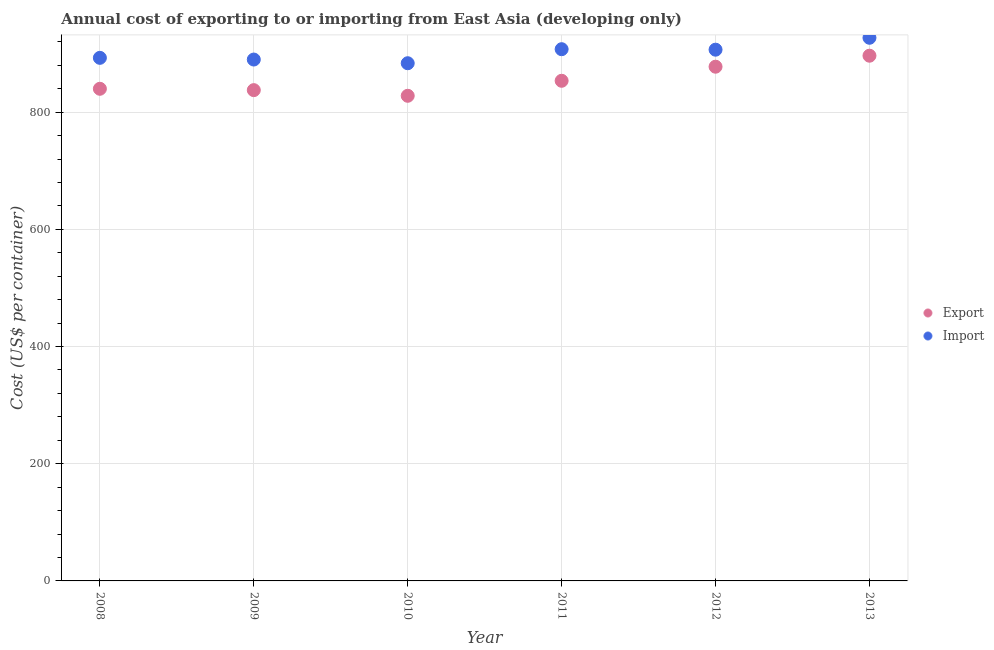Is the number of dotlines equal to the number of legend labels?
Ensure brevity in your answer.  Yes. What is the export cost in 2008?
Offer a terse response. 839.85. Across all years, what is the maximum export cost?
Provide a short and direct response. 896.3. Across all years, what is the minimum export cost?
Ensure brevity in your answer.  827.9. In which year was the export cost minimum?
Your answer should be very brief. 2010. What is the total export cost in the graph?
Provide a short and direct response. 5132.62. What is the difference between the export cost in 2008 and that in 2011?
Make the answer very short. -13.65. What is the difference between the import cost in 2011 and the export cost in 2013?
Your response must be concise. 11.1. What is the average import cost per year?
Ensure brevity in your answer.  901.12. In the year 2012, what is the difference between the import cost and export cost?
Provide a succinct answer. 29.05. What is the ratio of the import cost in 2010 to that in 2013?
Make the answer very short. 0.95. Is the export cost in 2008 less than that in 2011?
Keep it short and to the point. Yes. What is the difference between the highest and the second highest export cost?
Give a very brief answer. 18.77. What is the difference between the highest and the lowest export cost?
Keep it short and to the point. 68.4. In how many years, is the export cost greater than the average export cost taken over all years?
Offer a terse response. 2. Is the sum of the import cost in 2008 and 2011 greater than the maximum export cost across all years?
Offer a very short reply. Yes. Is the export cost strictly less than the import cost over the years?
Your answer should be very brief. Yes. How many dotlines are there?
Give a very brief answer. 2. How many years are there in the graph?
Your response must be concise. 6. What is the difference between two consecutive major ticks on the Y-axis?
Your response must be concise. 200. Are the values on the major ticks of Y-axis written in scientific E-notation?
Keep it short and to the point. No. Does the graph contain any zero values?
Your response must be concise. No. Does the graph contain grids?
Offer a very short reply. Yes. What is the title of the graph?
Provide a succinct answer. Annual cost of exporting to or importing from East Asia (developing only). What is the label or title of the Y-axis?
Your answer should be very brief. Cost (US$ per container). What is the Cost (US$ per container) in Export in 2008?
Keep it short and to the point. 839.85. What is the Cost (US$ per container) in Import in 2008?
Your answer should be compact. 892.65. What is the Cost (US$ per container) of Export in 2009?
Make the answer very short. 837.55. What is the Cost (US$ per container) of Import in 2009?
Offer a very short reply. 889.75. What is the Cost (US$ per container) in Export in 2010?
Offer a terse response. 827.9. What is the Cost (US$ per container) of Import in 2010?
Your answer should be compact. 883.45. What is the Cost (US$ per container) in Export in 2011?
Offer a terse response. 853.5. What is the Cost (US$ per container) of Import in 2011?
Provide a short and direct response. 907.4. What is the Cost (US$ per container) of Export in 2012?
Provide a succinct answer. 877.52. What is the Cost (US$ per container) in Import in 2012?
Give a very brief answer. 906.57. What is the Cost (US$ per container) in Export in 2013?
Give a very brief answer. 896.3. What is the Cost (US$ per container) in Import in 2013?
Provide a succinct answer. 926.9. Across all years, what is the maximum Cost (US$ per container) of Export?
Offer a very short reply. 896.3. Across all years, what is the maximum Cost (US$ per container) of Import?
Provide a succinct answer. 926.9. Across all years, what is the minimum Cost (US$ per container) in Export?
Offer a terse response. 827.9. Across all years, what is the minimum Cost (US$ per container) of Import?
Keep it short and to the point. 883.45. What is the total Cost (US$ per container) of Export in the graph?
Ensure brevity in your answer.  5132.62. What is the total Cost (US$ per container) of Import in the graph?
Keep it short and to the point. 5406.72. What is the difference between the Cost (US$ per container) of Import in 2008 and that in 2009?
Give a very brief answer. 2.9. What is the difference between the Cost (US$ per container) in Export in 2008 and that in 2010?
Offer a very short reply. 11.95. What is the difference between the Cost (US$ per container) in Import in 2008 and that in 2010?
Your answer should be compact. 9.2. What is the difference between the Cost (US$ per container) in Export in 2008 and that in 2011?
Offer a very short reply. -13.65. What is the difference between the Cost (US$ per container) in Import in 2008 and that in 2011?
Your response must be concise. -14.75. What is the difference between the Cost (US$ per container) of Export in 2008 and that in 2012?
Give a very brief answer. -37.67. What is the difference between the Cost (US$ per container) of Import in 2008 and that in 2012?
Keep it short and to the point. -13.92. What is the difference between the Cost (US$ per container) of Export in 2008 and that in 2013?
Offer a terse response. -56.45. What is the difference between the Cost (US$ per container) in Import in 2008 and that in 2013?
Ensure brevity in your answer.  -34.25. What is the difference between the Cost (US$ per container) in Export in 2009 and that in 2010?
Ensure brevity in your answer.  9.65. What is the difference between the Cost (US$ per container) in Import in 2009 and that in 2010?
Your answer should be compact. 6.3. What is the difference between the Cost (US$ per container) in Export in 2009 and that in 2011?
Give a very brief answer. -15.95. What is the difference between the Cost (US$ per container) in Import in 2009 and that in 2011?
Offer a very short reply. -17.65. What is the difference between the Cost (US$ per container) of Export in 2009 and that in 2012?
Give a very brief answer. -39.97. What is the difference between the Cost (US$ per container) in Import in 2009 and that in 2012?
Make the answer very short. -16.82. What is the difference between the Cost (US$ per container) of Export in 2009 and that in 2013?
Make the answer very short. -58.75. What is the difference between the Cost (US$ per container) of Import in 2009 and that in 2013?
Your answer should be compact. -37.15. What is the difference between the Cost (US$ per container) in Export in 2010 and that in 2011?
Provide a succinct answer. -25.6. What is the difference between the Cost (US$ per container) in Import in 2010 and that in 2011?
Keep it short and to the point. -23.95. What is the difference between the Cost (US$ per container) in Export in 2010 and that in 2012?
Offer a very short reply. -49.62. What is the difference between the Cost (US$ per container) in Import in 2010 and that in 2012?
Your answer should be very brief. -23.12. What is the difference between the Cost (US$ per container) of Export in 2010 and that in 2013?
Keep it short and to the point. -68.4. What is the difference between the Cost (US$ per container) in Import in 2010 and that in 2013?
Your answer should be compact. -43.45. What is the difference between the Cost (US$ per container) of Export in 2011 and that in 2012?
Keep it short and to the point. -24.02. What is the difference between the Cost (US$ per container) in Import in 2011 and that in 2012?
Provide a succinct answer. 0.83. What is the difference between the Cost (US$ per container) of Export in 2011 and that in 2013?
Give a very brief answer. -42.8. What is the difference between the Cost (US$ per container) of Import in 2011 and that in 2013?
Your answer should be very brief. -19.5. What is the difference between the Cost (US$ per container) of Export in 2012 and that in 2013?
Your response must be concise. -18.77. What is the difference between the Cost (US$ per container) of Import in 2012 and that in 2013?
Ensure brevity in your answer.  -20.32. What is the difference between the Cost (US$ per container) of Export in 2008 and the Cost (US$ per container) of Import in 2009?
Ensure brevity in your answer.  -49.9. What is the difference between the Cost (US$ per container) of Export in 2008 and the Cost (US$ per container) of Import in 2010?
Ensure brevity in your answer.  -43.6. What is the difference between the Cost (US$ per container) in Export in 2008 and the Cost (US$ per container) in Import in 2011?
Your answer should be compact. -67.55. What is the difference between the Cost (US$ per container) in Export in 2008 and the Cost (US$ per container) in Import in 2012?
Ensure brevity in your answer.  -66.72. What is the difference between the Cost (US$ per container) of Export in 2008 and the Cost (US$ per container) of Import in 2013?
Provide a succinct answer. -87.05. What is the difference between the Cost (US$ per container) of Export in 2009 and the Cost (US$ per container) of Import in 2010?
Ensure brevity in your answer.  -45.9. What is the difference between the Cost (US$ per container) in Export in 2009 and the Cost (US$ per container) in Import in 2011?
Offer a terse response. -69.85. What is the difference between the Cost (US$ per container) of Export in 2009 and the Cost (US$ per container) of Import in 2012?
Provide a succinct answer. -69.02. What is the difference between the Cost (US$ per container) in Export in 2009 and the Cost (US$ per container) in Import in 2013?
Keep it short and to the point. -89.35. What is the difference between the Cost (US$ per container) in Export in 2010 and the Cost (US$ per container) in Import in 2011?
Give a very brief answer. -79.5. What is the difference between the Cost (US$ per container) in Export in 2010 and the Cost (US$ per container) in Import in 2012?
Provide a succinct answer. -78.67. What is the difference between the Cost (US$ per container) of Export in 2010 and the Cost (US$ per container) of Import in 2013?
Your answer should be compact. -99. What is the difference between the Cost (US$ per container) in Export in 2011 and the Cost (US$ per container) in Import in 2012?
Offer a terse response. -53.07. What is the difference between the Cost (US$ per container) in Export in 2011 and the Cost (US$ per container) in Import in 2013?
Make the answer very short. -73.4. What is the difference between the Cost (US$ per container) in Export in 2012 and the Cost (US$ per container) in Import in 2013?
Provide a succinct answer. -49.37. What is the average Cost (US$ per container) of Export per year?
Provide a succinct answer. 855.44. What is the average Cost (US$ per container) of Import per year?
Ensure brevity in your answer.  901.12. In the year 2008, what is the difference between the Cost (US$ per container) of Export and Cost (US$ per container) of Import?
Offer a very short reply. -52.8. In the year 2009, what is the difference between the Cost (US$ per container) of Export and Cost (US$ per container) of Import?
Offer a terse response. -52.2. In the year 2010, what is the difference between the Cost (US$ per container) of Export and Cost (US$ per container) of Import?
Your response must be concise. -55.55. In the year 2011, what is the difference between the Cost (US$ per container) of Export and Cost (US$ per container) of Import?
Your answer should be compact. -53.9. In the year 2012, what is the difference between the Cost (US$ per container) of Export and Cost (US$ per container) of Import?
Ensure brevity in your answer.  -29.05. In the year 2013, what is the difference between the Cost (US$ per container) of Export and Cost (US$ per container) of Import?
Your answer should be compact. -30.6. What is the ratio of the Cost (US$ per container) of Export in 2008 to that in 2010?
Your answer should be compact. 1.01. What is the ratio of the Cost (US$ per container) in Import in 2008 to that in 2010?
Your answer should be compact. 1.01. What is the ratio of the Cost (US$ per container) of Import in 2008 to that in 2011?
Offer a very short reply. 0.98. What is the ratio of the Cost (US$ per container) of Export in 2008 to that in 2012?
Offer a very short reply. 0.96. What is the ratio of the Cost (US$ per container) of Import in 2008 to that in 2012?
Your answer should be very brief. 0.98. What is the ratio of the Cost (US$ per container) in Export in 2008 to that in 2013?
Keep it short and to the point. 0.94. What is the ratio of the Cost (US$ per container) in Import in 2008 to that in 2013?
Offer a terse response. 0.96. What is the ratio of the Cost (US$ per container) in Export in 2009 to that in 2010?
Offer a very short reply. 1.01. What is the ratio of the Cost (US$ per container) of Import in 2009 to that in 2010?
Your answer should be compact. 1.01. What is the ratio of the Cost (US$ per container) in Export in 2009 to that in 2011?
Your response must be concise. 0.98. What is the ratio of the Cost (US$ per container) in Import in 2009 to that in 2011?
Make the answer very short. 0.98. What is the ratio of the Cost (US$ per container) of Export in 2009 to that in 2012?
Your response must be concise. 0.95. What is the ratio of the Cost (US$ per container) of Import in 2009 to that in 2012?
Provide a short and direct response. 0.98. What is the ratio of the Cost (US$ per container) of Export in 2009 to that in 2013?
Ensure brevity in your answer.  0.93. What is the ratio of the Cost (US$ per container) of Import in 2009 to that in 2013?
Offer a very short reply. 0.96. What is the ratio of the Cost (US$ per container) of Export in 2010 to that in 2011?
Keep it short and to the point. 0.97. What is the ratio of the Cost (US$ per container) in Import in 2010 to that in 2011?
Provide a succinct answer. 0.97. What is the ratio of the Cost (US$ per container) of Export in 2010 to that in 2012?
Provide a short and direct response. 0.94. What is the ratio of the Cost (US$ per container) of Import in 2010 to that in 2012?
Provide a short and direct response. 0.97. What is the ratio of the Cost (US$ per container) in Export in 2010 to that in 2013?
Provide a short and direct response. 0.92. What is the ratio of the Cost (US$ per container) in Import in 2010 to that in 2013?
Your answer should be compact. 0.95. What is the ratio of the Cost (US$ per container) in Export in 2011 to that in 2012?
Ensure brevity in your answer.  0.97. What is the ratio of the Cost (US$ per container) of Import in 2011 to that in 2012?
Offer a terse response. 1. What is the ratio of the Cost (US$ per container) in Export in 2011 to that in 2013?
Ensure brevity in your answer.  0.95. What is the ratio of the Cost (US$ per container) of Import in 2011 to that in 2013?
Offer a very short reply. 0.98. What is the ratio of the Cost (US$ per container) of Export in 2012 to that in 2013?
Provide a succinct answer. 0.98. What is the ratio of the Cost (US$ per container) in Import in 2012 to that in 2013?
Give a very brief answer. 0.98. What is the difference between the highest and the second highest Cost (US$ per container) in Export?
Provide a short and direct response. 18.77. What is the difference between the highest and the second highest Cost (US$ per container) of Import?
Keep it short and to the point. 19.5. What is the difference between the highest and the lowest Cost (US$ per container) in Export?
Offer a terse response. 68.4. What is the difference between the highest and the lowest Cost (US$ per container) in Import?
Make the answer very short. 43.45. 